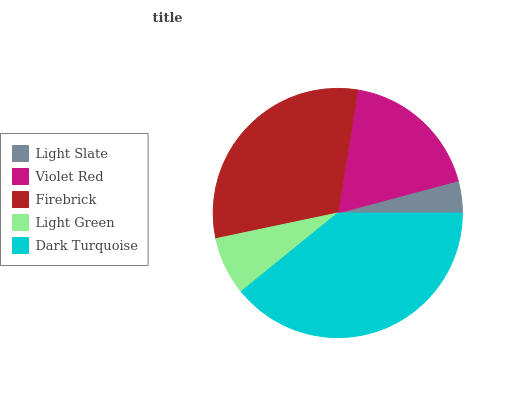Is Light Slate the minimum?
Answer yes or no. Yes. Is Dark Turquoise the maximum?
Answer yes or no. Yes. Is Violet Red the minimum?
Answer yes or no. No. Is Violet Red the maximum?
Answer yes or no. No. Is Violet Red greater than Light Slate?
Answer yes or no. Yes. Is Light Slate less than Violet Red?
Answer yes or no. Yes. Is Light Slate greater than Violet Red?
Answer yes or no. No. Is Violet Red less than Light Slate?
Answer yes or no. No. Is Violet Red the high median?
Answer yes or no. Yes. Is Violet Red the low median?
Answer yes or no. Yes. Is Dark Turquoise the high median?
Answer yes or no. No. Is Firebrick the low median?
Answer yes or no. No. 